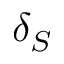<formula> <loc_0><loc_0><loc_500><loc_500>\delta _ { S }</formula> 